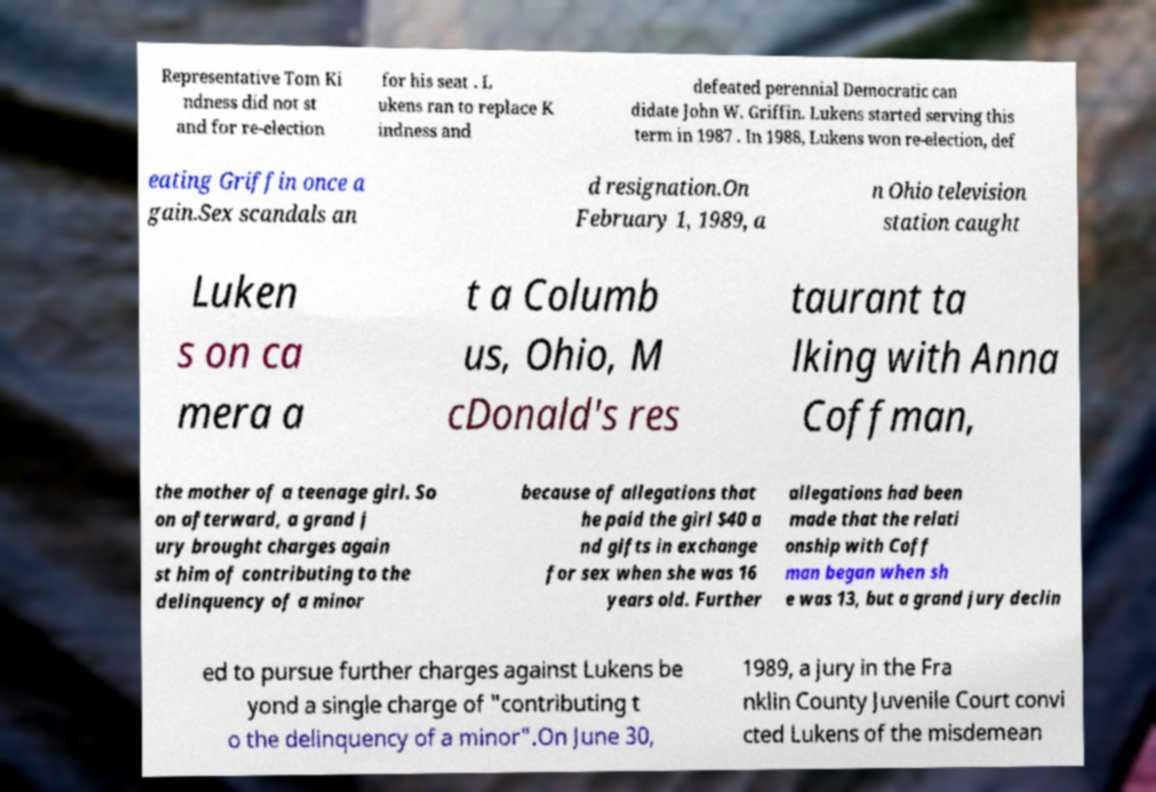For documentation purposes, I need the text within this image transcribed. Could you provide that? Representative Tom Ki ndness did not st and for re-election for his seat . L ukens ran to replace K indness and defeated perennial Democratic can didate John W. Griffin. Lukens started serving this term in 1987 . In 1988, Lukens won re-election, def eating Griffin once a gain.Sex scandals an d resignation.On February 1, 1989, a n Ohio television station caught Luken s on ca mera a t a Columb us, Ohio, M cDonald's res taurant ta lking with Anna Coffman, the mother of a teenage girl. So on afterward, a grand j ury brought charges again st him of contributing to the delinquency of a minor because of allegations that he paid the girl $40 a nd gifts in exchange for sex when she was 16 years old. Further allegations had been made that the relati onship with Coff man began when sh e was 13, but a grand jury declin ed to pursue further charges against Lukens be yond a single charge of "contributing t o the delinquency of a minor".On June 30, 1989, a jury in the Fra nklin County Juvenile Court convi cted Lukens of the misdemean 